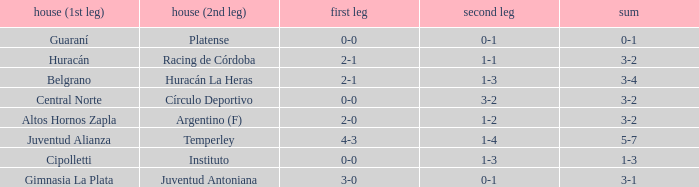Which team played their first leg at home with an aggregate score of 3-4? Belgrano. 